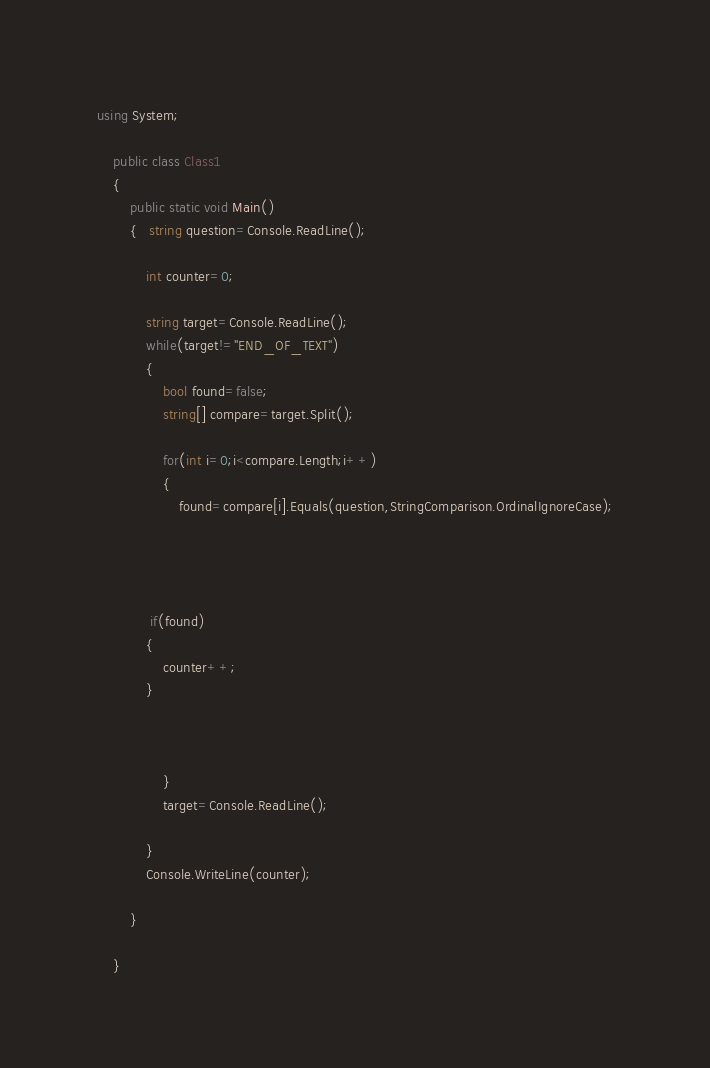Convert code to text. <code><loc_0><loc_0><loc_500><loc_500><_C#_>using System;

	public class Class1
	{
		public static void Main()
		{   string question=Console.ReadLine();
		
			int counter=0;
			
			string target=Console.ReadLine();
		    while(target!="END_OF_TEXT")
		    {
		    	bool found=false;
		    	string[] compare=target.Split();
		   
		    	for(int i=0;i<compare.Length;i++)
		    	{
		    		found=compare[i].Equals(question,StringComparison.OrdinalIgnoreCase);
		    		
		    
		    			    
		    
		     if(found)
		    {
		     	counter++;
		    }
		 
		    
		     
		    	}
		    	target=Console.ReadLine();
				
			}
		    Console.WriteLine(counter);
		    
		}
		
	}</code> 